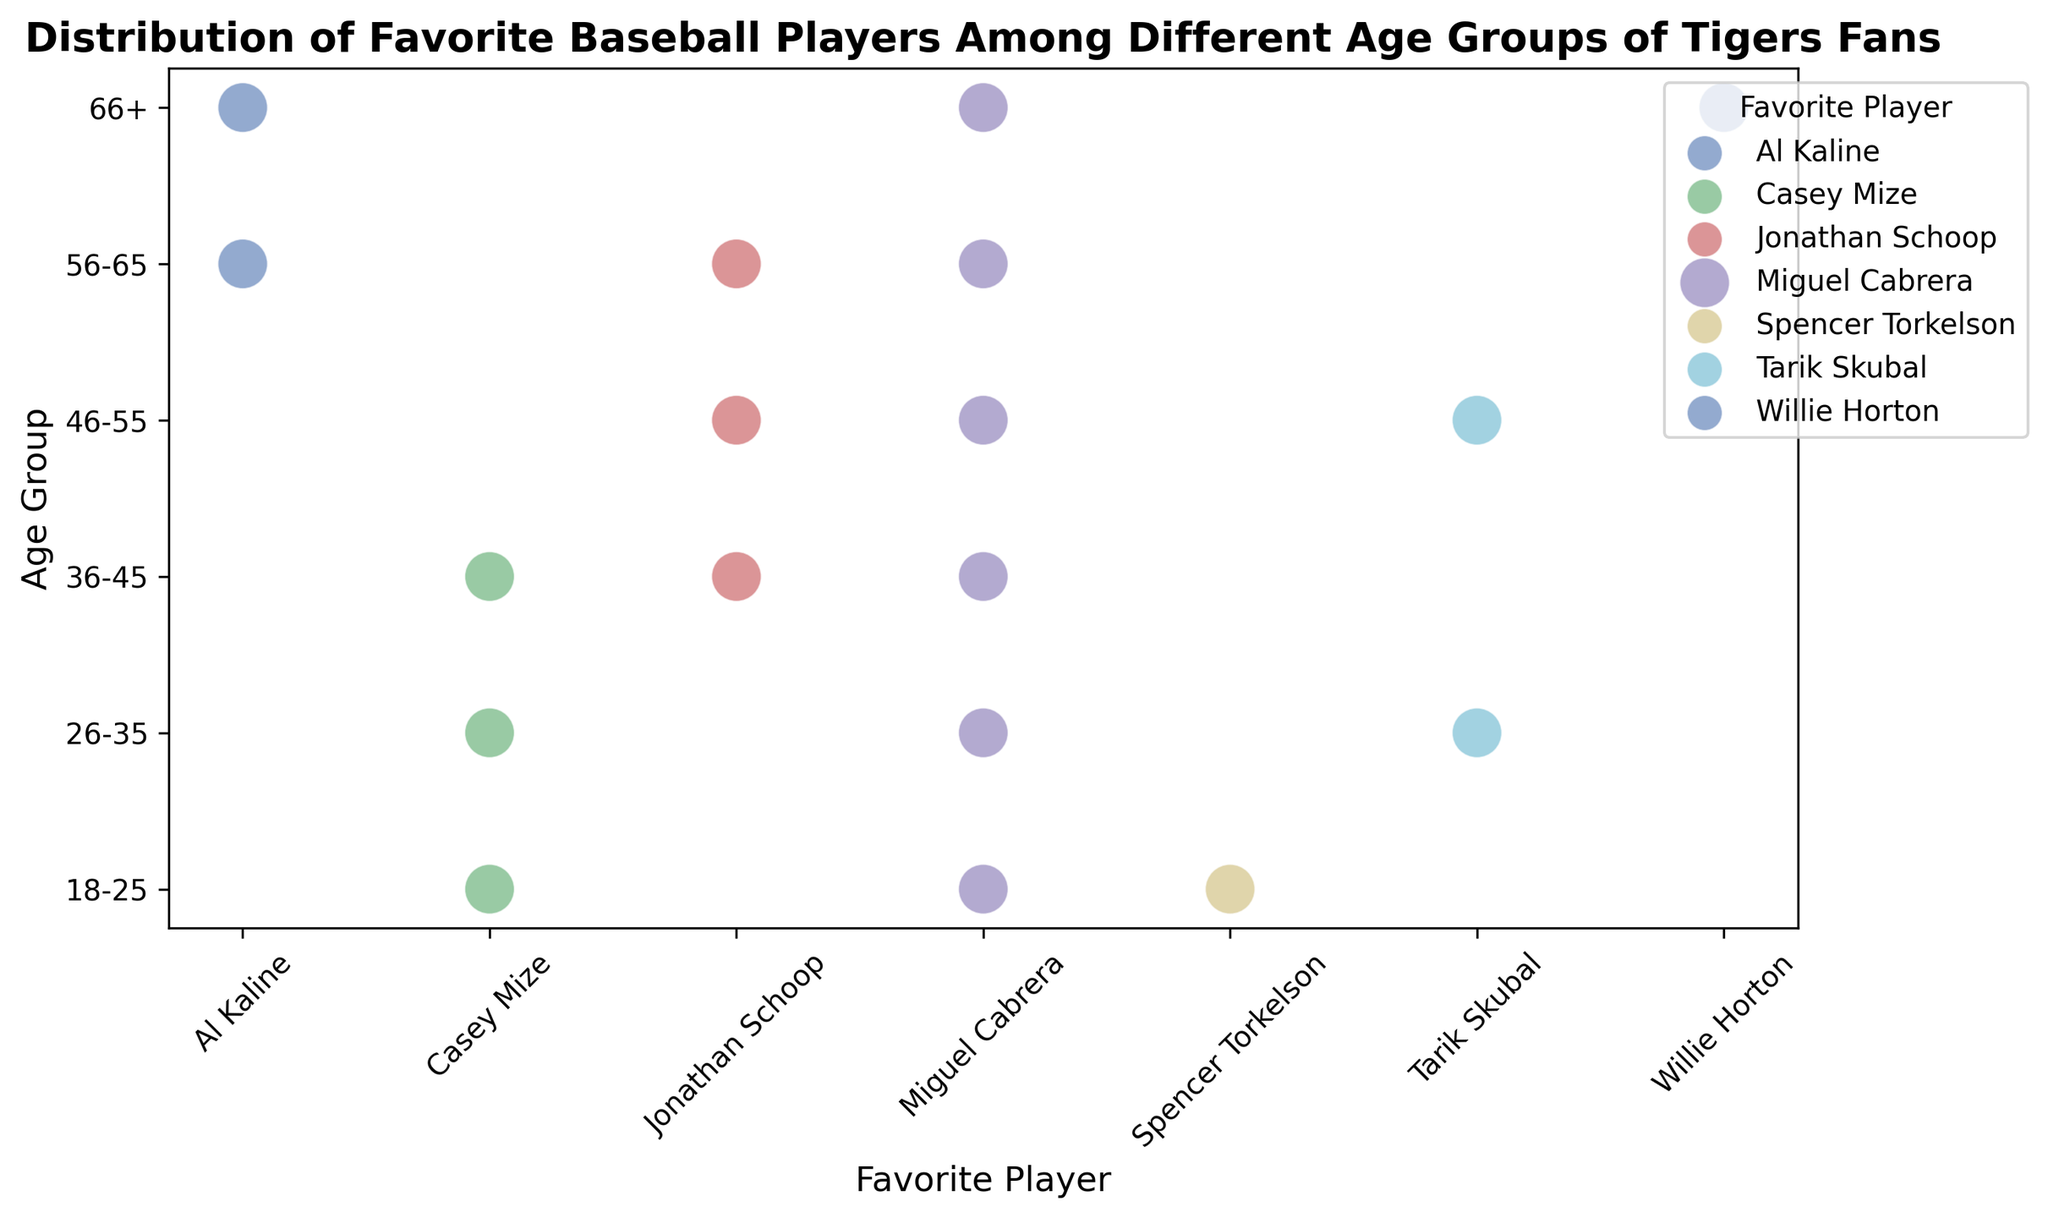How many age groups have Miguel Cabrera as a favorite player? Count the number of unique age groups where Miguel Cabrera's dot is present. His dot appears in 5 age groups (18-25, 26-35, 36-45, 46-55, 56-65).
Answer: 5 Which player is popular among the 66+ age group? Look at the scatter plot and identify which dots are in the 66+ row. Miguel Cabrera, Al Kaline, and Willie Horton are seen.
Answer: Miguel Cabrera, Al Kaline, Willie Horton Among the age groups 26-35 and 36-45, which group has more fans for Casey Mize? Compare the sizes of the dots for Casey Mize in the 26-35 and 36-45 rows. Both groups have dots, but 36-45 has a smaller dot (representing fewer fans).
Answer: 26-35 What is the combined total of age groups where Casey Mize and Jonathan Schoop are favorite players? Count the unique age groups for each player and then add. Casey Mize appears in 4 (18-25, 26-35, 36-45, 46-55) and Jonathan Schoop in 3 (36-45, 46-55, 56-65). Combined total counting the overlap is 5 unique age groups (18-25, 26-35, 36-45, 46-55, 56-65).
Answer: 5 Which age group has the highest variety of favorite players? Count the number of different players' dots in each age group and find the maximum. The 18-25 age group shows 3 different players (Miguel Cabrera, Casey Mize, Spencer Torkelson), which is the highest in count.
Answer: 18-25 Compare the popularity of Al Kaline between the 56-65 and 66+ age groups. Look at the dots for Al Kaline in both age groups; the dot size in the 66+ group is larger, indicating more fans compared to the 56-65 group.
Answer: 66+ age group In how many age groups does Tarik Skubal appear as a favorite player, and in which groups? Identify and count the age groups where Tarik Skubal's dot is present. He appears in the 26-35 and 46-55 groups.
Answer: 2, 26-35 and 46-55 